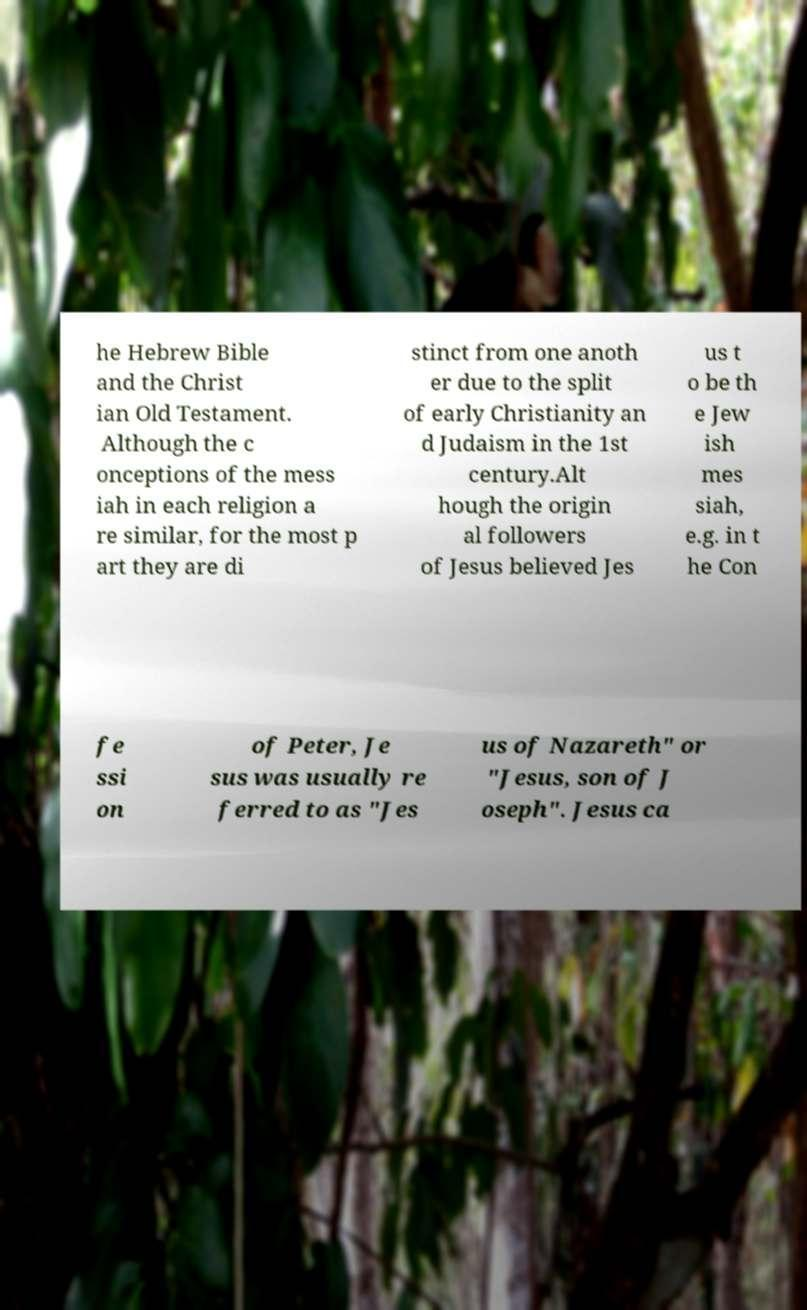Could you assist in decoding the text presented in this image and type it out clearly? he Hebrew Bible and the Christ ian Old Testament. Although the c onceptions of the mess iah in each religion a re similar, for the most p art they are di stinct from one anoth er due to the split of early Christianity an d Judaism in the 1st century.Alt hough the origin al followers of Jesus believed Jes us t o be th e Jew ish mes siah, e.g. in t he Con fe ssi on of Peter, Je sus was usually re ferred to as "Jes us of Nazareth" or "Jesus, son of J oseph". Jesus ca 